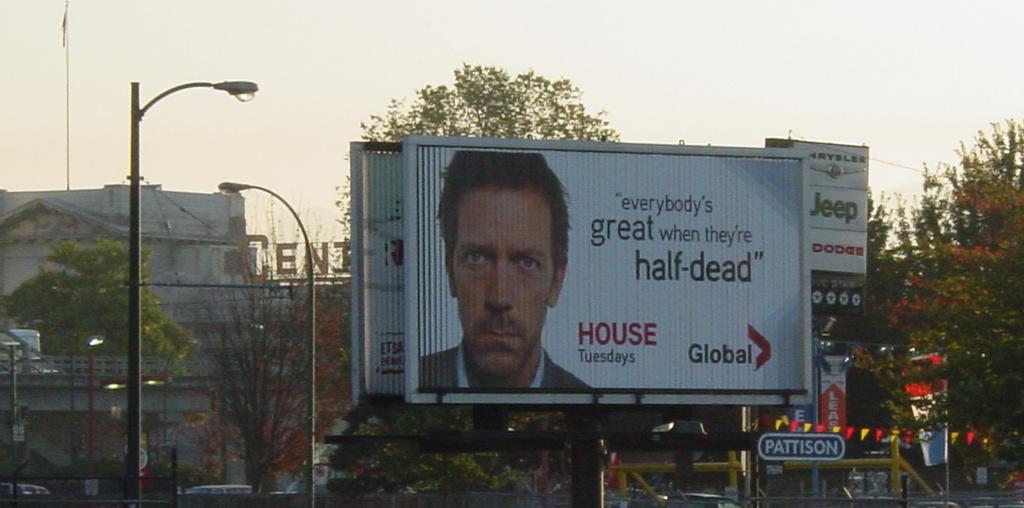What is the name of the television show on the board?
Your response must be concise. House. What is the title of the advertised program?
Your answer should be compact. House. 